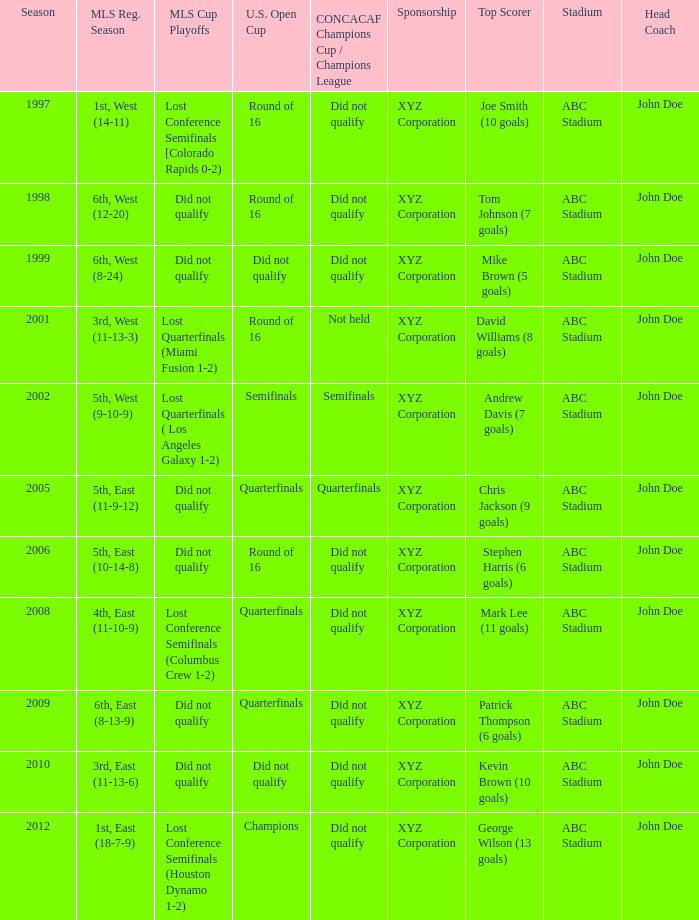Can you give me this table as a dict? {'header': ['Season', 'MLS Reg. Season', 'MLS Cup Playoffs', 'U.S. Open Cup', 'CONCACAF Champions Cup / Champions League', 'Sponsorship', 'Top Scorer', 'Stadium', 'Head Coach'], 'rows': [['1997', '1st, West (14-11)', 'Lost Conference Semifinals [Colorado Rapids 0-2)', 'Round of 16', 'Did not qualify', 'XYZ Corporation', 'Joe Smith (10 goals)', 'ABC Stadium', 'John Doe'], ['1998', '6th, West (12-20)', 'Did not qualify', 'Round of 16', 'Did not qualify', 'XYZ Corporation', 'Tom Johnson (7 goals)', 'ABC Stadium', 'John Doe'], ['1999', '6th, West (8-24)', 'Did not qualify', 'Did not qualify', 'Did not qualify', 'XYZ Corporation', 'Mike Brown (5 goals)', 'ABC Stadium', 'John Doe'], ['2001', '3rd, West (11-13-3)', 'Lost Quarterfinals (Miami Fusion 1-2)', 'Round of 16', 'Not held', 'XYZ Corporation', 'David Williams (8 goals)', 'ABC Stadium', 'John Doe'], ['2002', '5th, West (9-10-9)', 'Lost Quarterfinals ( Los Angeles Galaxy 1-2)', 'Semifinals', 'Semifinals', 'XYZ Corporation', 'Andrew Davis (7 goals)', 'ABC Stadium', 'John Doe'], ['2005', '5th, East (11-9-12)', 'Did not qualify', 'Quarterfinals', 'Quarterfinals', 'XYZ Corporation', 'Chris Jackson (9 goals)', 'ABC Stadium', 'John Doe'], ['2006', '5th, East (10-14-8)', 'Did not qualify', 'Round of 16', 'Did not qualify', 'XYZ Corporation', 'Stephen Harris (6 goals)', 'ABC Stadium', 'John Doe'], ['2008', '4th, East (11-10-9)', 'Lost Conference Semifinals (Columbus Crew 1-2)', 'Quarterfinals', 'Did not qualify', 'XYZ Corporation', 'Mark Lee (11 goals)', 'ABC Stadium', 'John Doe'], ['2009', '6th, East (8-13-9)', 'Did not qualify', 'Quarterfinals', 'Did not qualify', 'XYZ Corporation', 'Patrick Thompson (6 goals)', 'ABC Stadium', 'John Doe'], ['2010', '3rd, East (11-13-6)', 'Did not qualify', 'Did not qualify', 'Did not qualify', 'XYZ Corporation', 'Kevin Brown (10 goals)', 'ABC Stadium', 'John Doe'], ['2012', '1st, East (18-7-9)', 'Lost Conference Semifinals (Houston Dynamo 1-2)', 'Champions', 'Did not qualify', 'XYZ Corporation', 'George Wilson (13 goals)', 'ABC Stadium', 'John Doe']]} How did the team place when they did not qualify for the Concaf Champions Cup but made it to Round of 16 in the U.S. Open Cup? Lost Conference Semifinals [Colorado Rapids 0-2), Did not qualify, Did not qualify. 